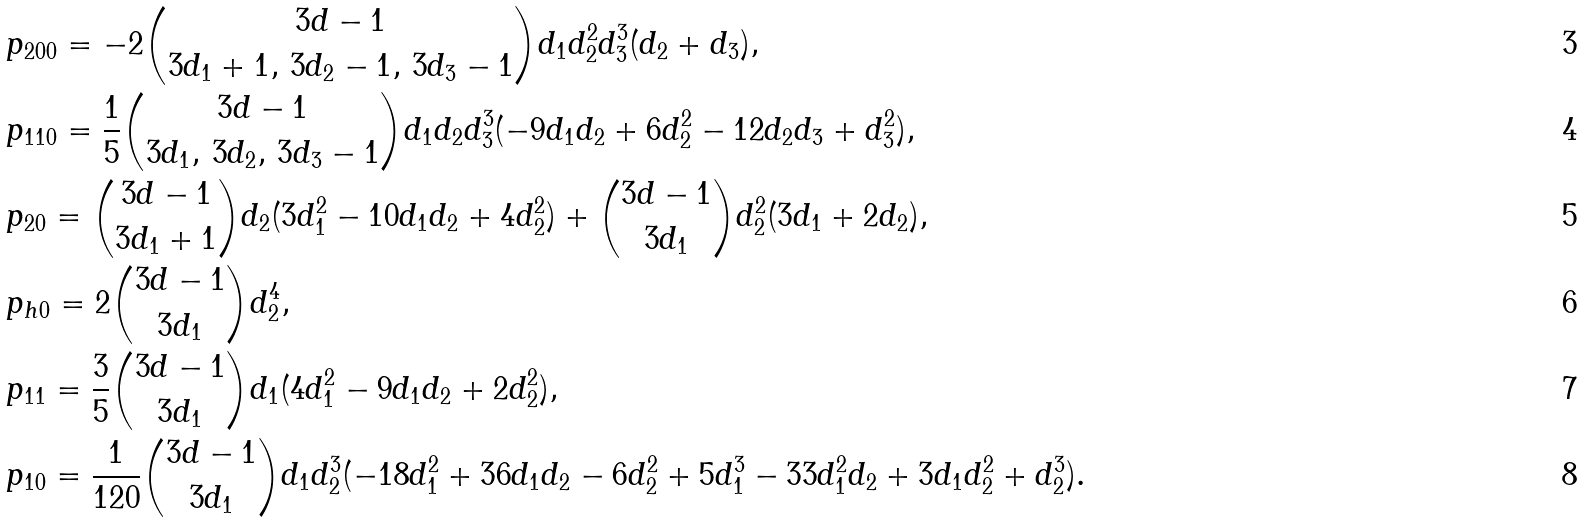Convert formula to latex. <formula><loc_0><loc_0><loc_500><loc_500>& p _ { 2 0 0 } = { - 2 \binom { 3 d - 1 } { 3 d _ { 1 } + 1 , \, 3 d _ { 2 } - 1 , \, 3 d _ { 3 } - 1 } d _ { 1 } d _ { 2 } ^ { 2 } d _ { 3 } ^ { 3 } ( d _ { 2 } + d _ { 3 } ) } , \\ & p _ { 1 1 0 } = { \frac { 1 } { 5 } \binom { 3 d - 1 } { 3 d _ { 1 } , \, 3 d _ { 2 } , \, 3 d _ { 3 } - 1 } d _ { 1 } d _ { 2 } d _ { 3 } ^ { 3 } ( - 9 d _ { 1 } d _ { 2 } + 6 d _ { 2 } ^ { 2 } - 1 2 d _ { 2 } d _ { 3 } + d _ { 3 } ^ { 2 } ) } , \\ & p _ { 2 0 } = { \binom { 3 d - 1 } { 3 d _ { 1 } + 1 } d _ { 2 } ( 3 d _ { 1 } ^ { 2 } - 1 0 d _ { 1 } d _ { 2 } + 4 d _ { 2 } ^ { 2 } ) + \binom { 3 d - 1 } { 3 d _ { 1 } } d _ { 2 } ^ { 2 } ( 3 d _ { 1 } + 2 d _ { 2 } ) } , \\ & p _ { h 0 } = { 2 \binom { 3 d - 1 } { 3 d _ { 1 } } d _ { 2 } ^ { 4 } } , \\ & p _ { 1 1 } = { \frac { 3 } { 5 } \binom { 3 d - 1 } { 3 d _ { 1 } } d _ { 1 } ( 4 d _ { 1 } ^ { 2 } - 9 d _ { 1 } d _ { 2 } + 2 d _ { 2 } ^ { 2 } ) } , \\ & p _ { 1 0 } = { \frac { 1 } { 1 2 0 } \binom { 3 d - 1 } { 3 d _ { 1 } } d _ { 1 } d _ { 2 } ^ { 3 } ( - 1 8 d _ { 1 } ^ { 2 } + 3 6 d _ { 1 } d _ { 2 } - 6 d _ { 2 } ^ { 2 } + 5 d _ { 1 } ^ { 3 } - 3 3 d _ { 1 } ^ { 2 } d _ { 2 } + 3 d _ { 1 } d _ { 2 } ^ { 2 } + d _ { 2 } ^ { 3 } ) } .</formula> 